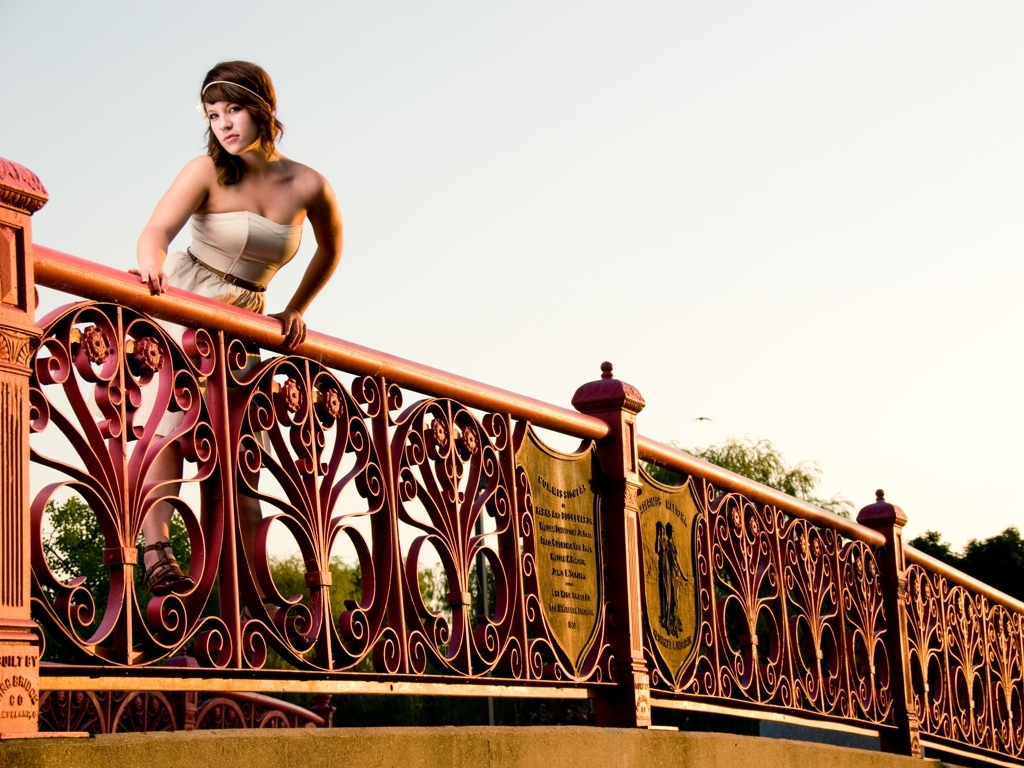What emotions does the woman's pose convey? The woman's pose, with her gaze directed outwards and body slightly leaning over the railing, seems to convey a mixture of contemplation and yearning. There's a nuanced expression of introspection that is complemented by the tranquil setting, evoking a poignant and reflective atmosphere. 